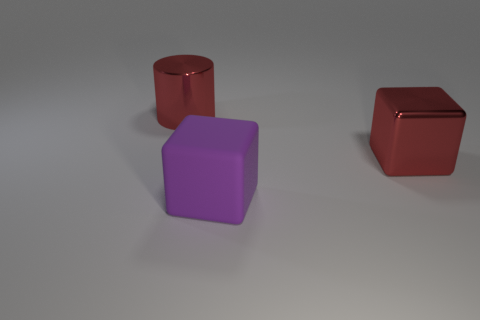Add 1 large metal cylinders. How many objects exist? 4 Subtract all cubes. How many objects are left? 1 Subtract all tiny purple rubber cylinders. Subtract all big red metal things. How many objects are left? 1 Add 2 large blocks. How many large blocks are left? 4 Add 1 rubber cubes. How many rubber cubes exist? 2 Subtract 0 green cubes. How many objects are left? 3 